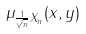Convert formula to latex. <formula><loc_0><loc_0><loc_500><loc_500>\mu _ { \frac { 1 } { \sqrt { n } } X _ { n } } ( x , y )</formula> 